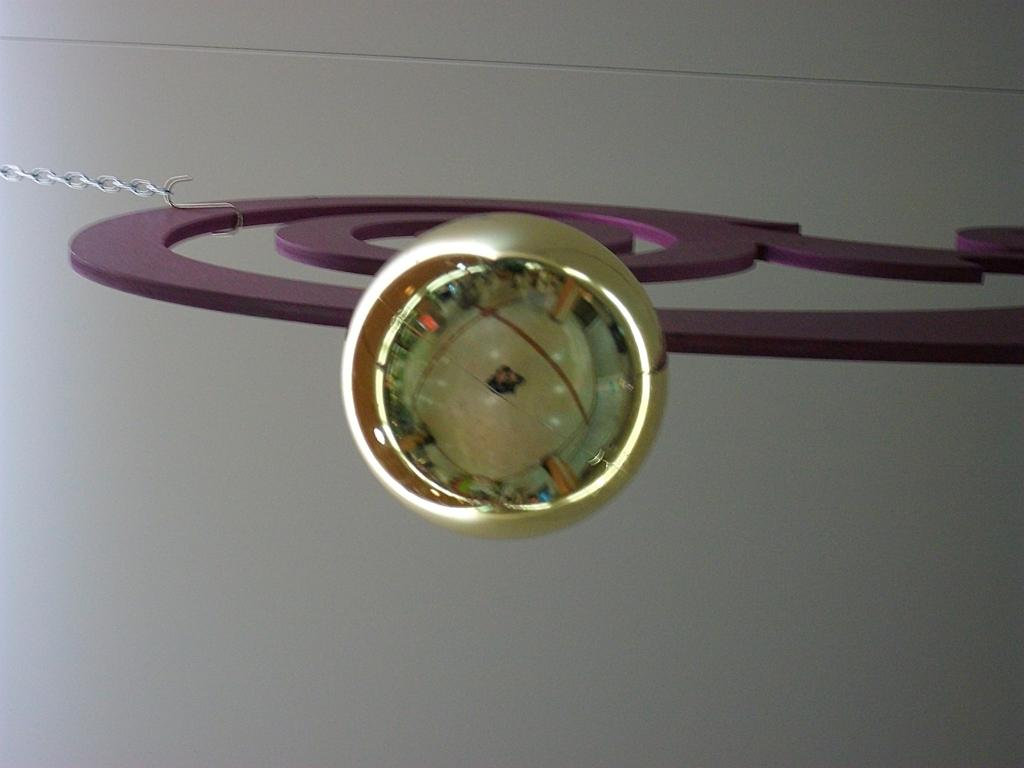What can be seen on the left side of the image? There is a chain on the left side of the image. What is the background of the image? There is a wall in the background of the image. Can you describe the unspecified object in the image? Unfortunately, the facts provided do not give any details about the unspecified object in the image. What type of kite is being used to stamp the soap in the image? There is no kite, soap, or stamp present in the image. 